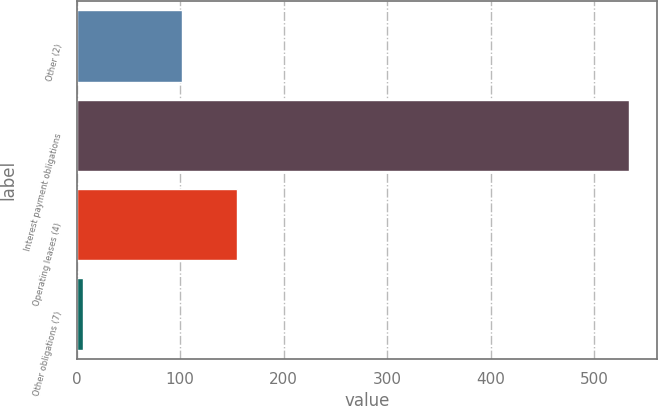Convert chart to OTSL. <chart><loc_0><loc_0><loc_500><loc_500><bar_chart><fcel>Other (2)<fcel>Interest payment obligations<fcel>Operating leases (4)<fcel>Other obligations (7)<nl><fcel>102<fcel>534<fcel>154.8<fcel>6<nl></chart> 